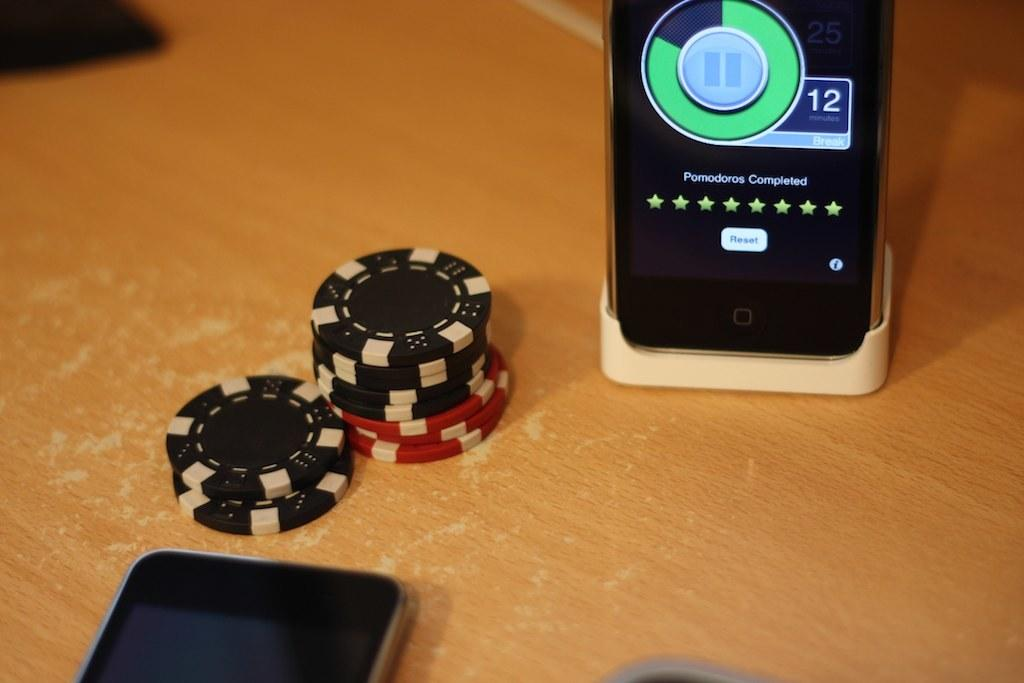<image>
Share a concise interpretation of the image provided. an electronic device with the number 12 on it digitally 